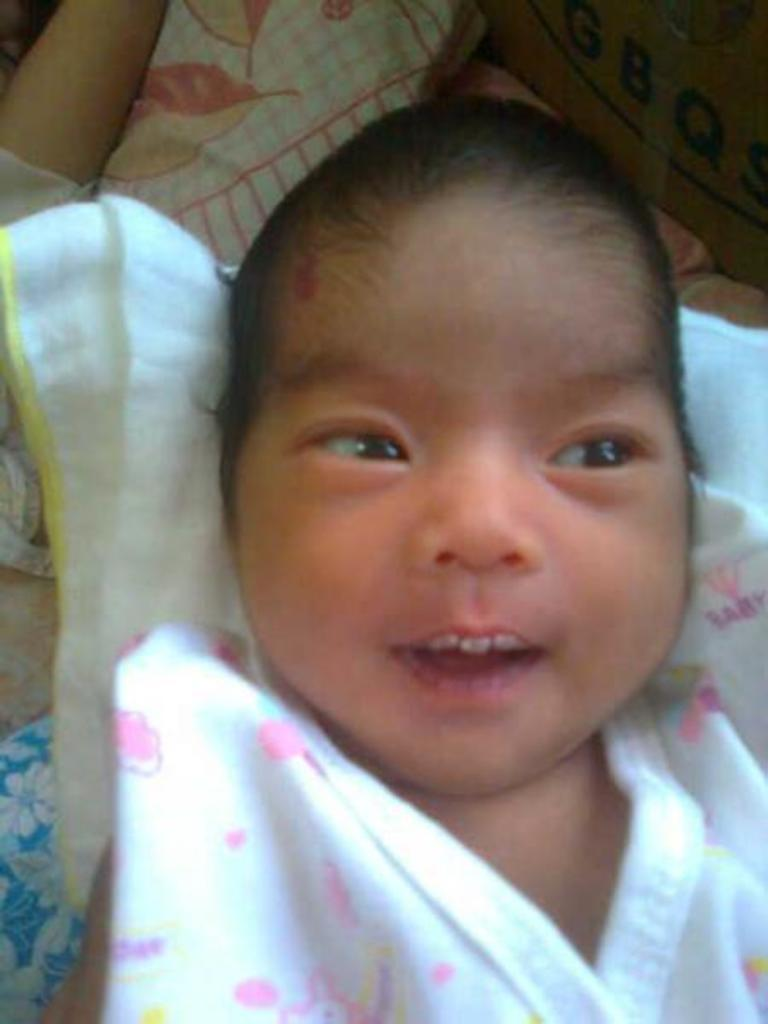What is the main subject of the image? The main subject of the image is an infant. Where is the infant located in the image? The infant is lying on a bed. What type of produce is being discussed at the meeting in the image? There is no meeting or produce present in the image; it features an infant lying on a bed. 